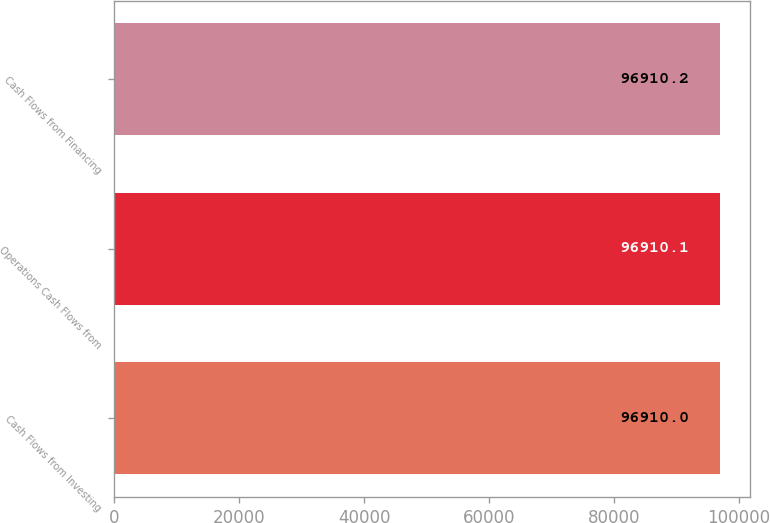Convert chart. <chart><loc_0><loc_0><loc_500><loc_500><bar_chart><fcel>Cash Flows from Investing<fcel>Operations Cash Flows from<fcel>Cash Flows from Financing<nl><fcel>96910<fcel>96910.1<fcel>96910.2<nl></chart> 